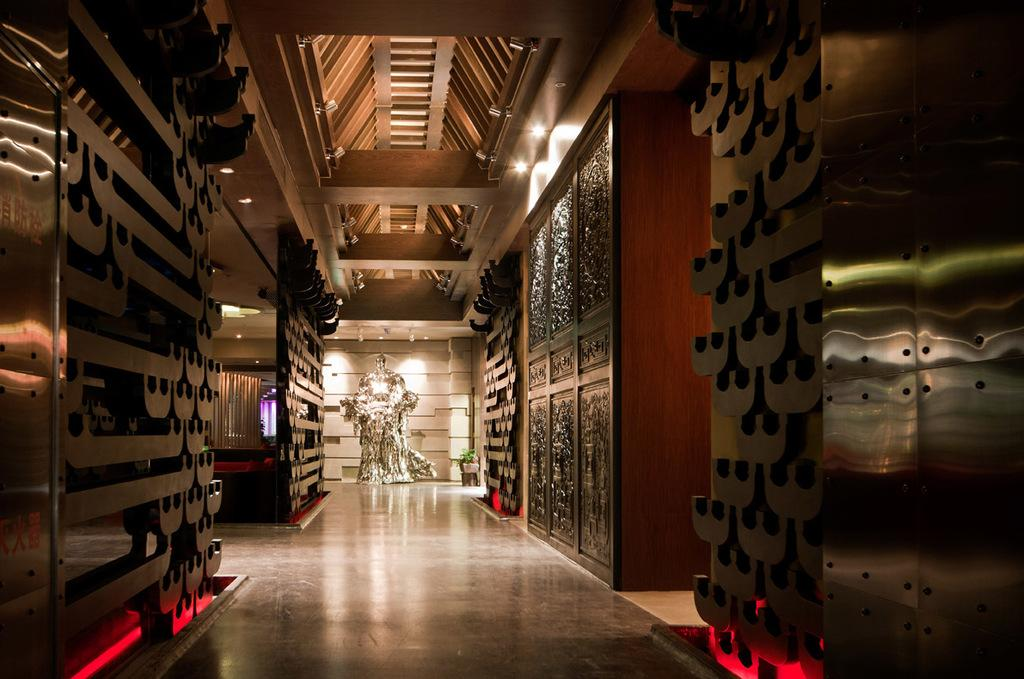What type of structure can be seen in the image? There is a wall in the image, which suggests a building or room. Are there any openings in the wall? Yes, there are doors in the image. What is visible on the rooftop? There are lights on the rooftop. What type of plant is present in the image? There is a house plant in the image. What can be found on the floor? There are objects on the floor. Can you see a footprint on the floor in the image? There is no mention of a footprint in the image, so we cannot confirm its presence. Are there any clams visible in the image? There is no mention of clams in the image, so we cannot confirm their presence. 